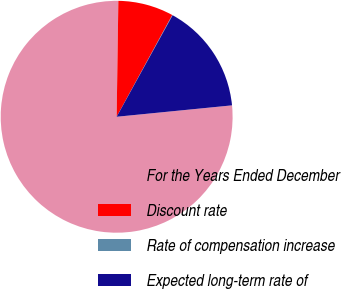<chart> <loc_0><loc_0><loc_500><loc_500><pie_chart><fcel>For the Years Ended December<fcel>Discount rate<fcel>Rate of compensation increase<fcel>Expected long-term rate of<nl><fcel>76.81%<fcel>7.73%<fcel>0.06%<fcel>15.41%<nl></chart> 